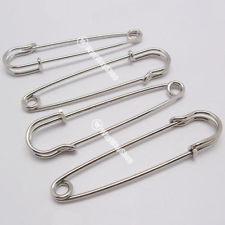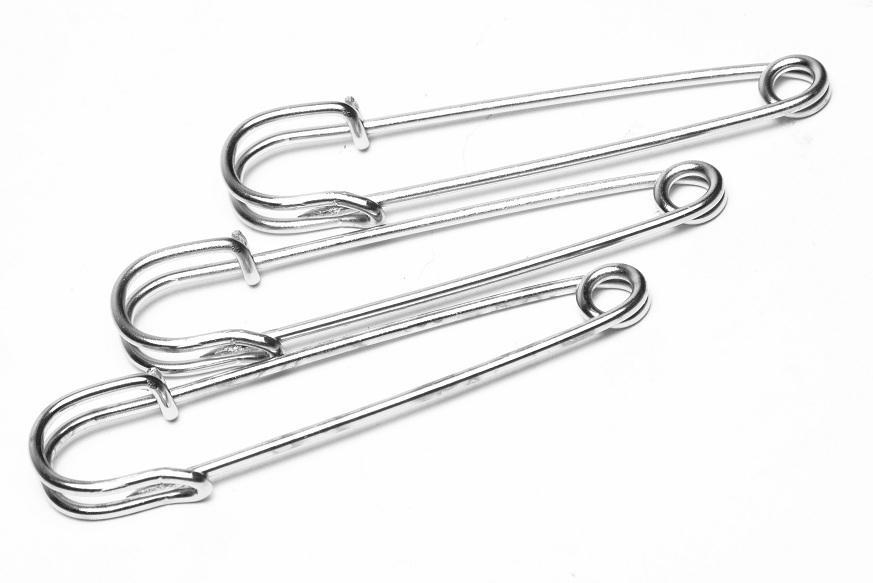The first image is the image on the left, the second image is the image on the right. Assess this claim about the two images: "One image contains a single, open safety pin, and the other image shows two closed pins of a different style.". Correct or not? Answer yes or no. No. The first image is the image on the left, the second image is the image on the right. Considering the images on both sides, is "The right image contains exactly two safety pins." valid? Answer yes or no. No. 